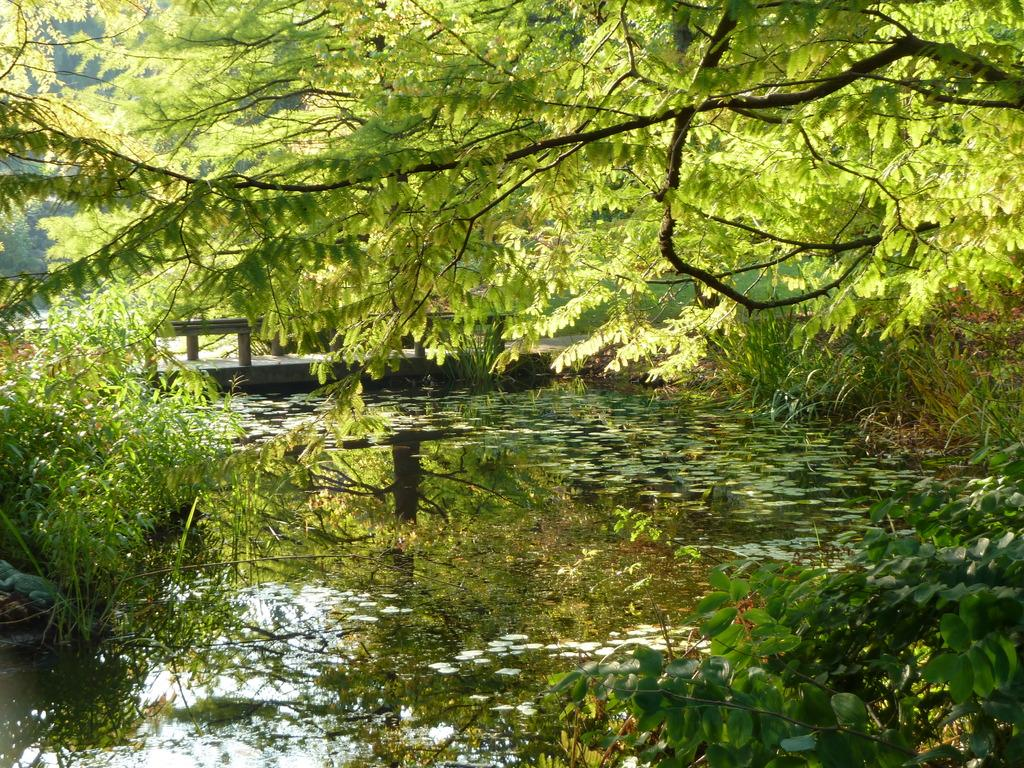What is the primary element visible in the image? There is water in the image. What structure can be seen in the center of the image? There is a bridge in the center of the image. What type of vegetation is present in the image? There are plants and trees in the image. Where is the volcano located in the image? There is no volcano present in the image. What type of ground can be seen beneath the trees in the image? The provided facts do not mention the ground beneath the trees, so it cannot be determined from the image. 